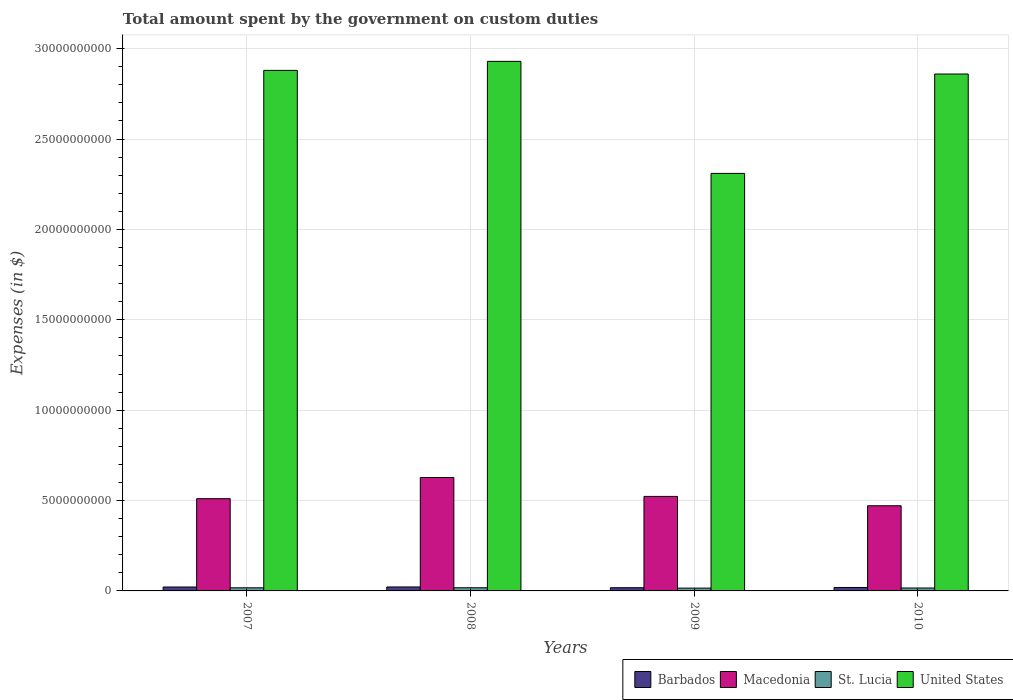How many groups of bars are there?
Ensure brevity in your answer.  4. Are the number of bars per tick equal to the number of legend labels?
Ensure brevity in your answer.  Yes. How many bars are there on the 2nd tick from the left?
Keep it short and to the point. 4. How many bars are there on the 4th tick from the right?
Give a very brief answer. 4. What is the label of the 2nd group of bars from the left?
Your answer should be compact. 2008. In how many cases, is the number of bars for a given year not equal to the number of legend labels?
Offer a very short reply. 0. What is the amount spent on custom duties by the government in United States in 2010?
Your answer should be very brief. 2.86e+1. Across all years, what is the maximum amount spent on custom duties by the government in United States?
Offer a terse response. 2.93e+1. Across all years, what is the minimum amount spent on custom duties by the government in Barbados?
Make the answer very short. 1.78e+08. In which year was the amount spent on custom duties by the government in United States maximum?
Offer a very short reply. 2008. What is the total amount spent on custom duties by the government in Macedonia in the graph?
Provide a short and direct response. 2.13e+1. What is the difference between the amount spent on custom duties by the government in United States in 2007 and that in 2008?
Keep it short and to the point. -5.00e+08. What is the difference between the amount spent on custom duties by the government in United States in 2007 and the amount spent on custom duties by the government in Barbados in 2010?
Make the answer very short. 2.86e+1. What is the average amount spent on custom duties by the government in Barbados per year?
Give a very brief answer. 2.01e+08. In the year 2007, what is the difference between the amount spent on custom duties by the government in Barbados and amount spent on custom duties by the government in Macedonia?
Give a very brief answer. -4.89e+09. In how many years, is the amount spent on custom duties by the government in United States greater than 23000000000 $?
Offer a terse response. 4. What is the ratio of the amount spent on custom duties by the government in St. Lucia in 2009 to that in 2010?
Your response must be concise. 0.96. Is the difference between the amount spent on custom duties by the government in Barbados in 2008 and 2009 greater than the difference between the amount spent on custom duties by the government in Macedonia in 2008 and 2009?
Your answer should be very brief. No. What is the difference between the highest and the second highest amount spent on custom duties by the government in St. Lucia?
Provide a short and direct response. 3.30e+06. What is the difference between the highest and the lowest amount spent on custom duties by the government in St. Lucia?
Your answer should be compact. 2.05e+07. What does the 1st bar from the left in 2008 represents?
Your answer should be compact. Barbados. What does the 3rd bar from the right in 2010 represents?
Ensure brevity in your answer.  Macedonia. Is it the case that in every year, the sum of the amount spent on custom duties by the government in Barbados and amount spent on custom duties by the government in United States is greater than the amount spent on custom duties by the government in Macedonia?
Provide a short and direct response. Yes. How many bars are there?
Provide a short and direct response. 16. How many years are there in the graph?
Provide a short and direct response. 4. What is the difference between two consecutive major ticks on the Y-axis?
Your answer should be very brief. 5.00e+09. Does the graph contain grids?
Your response must be concise. Yes. How are the legend labels stacked?
Make the answer very short. Horizontal. What is the title of the graph?
Give a very brief answer. Total amount spent by the government on custom duties. Does "Congo (Republic)" appear as one of the legend labels in the graph?
Offer a terse response. No. What is the label or title of the Y-axis?
Your answer should be very brief. Expenses (in $). What is the Expenses (in $) in Barbados in 2007?
Your answer should be compact. 2.17e+08. What is the Expenses (in $) in Macedonia in 2007?
Offer a terse response. 5.10e+09. What is the Expenses (in $) in St. Lucia in 2007?
Keep it short and to the point. 1.72e+08. What is the Expenses (in $) of United States in 2007?
Your response must be concise. 2.88e+1. What is the Expenses (in $) in Barbados in 2008?
Your answer should be compact. 2.19e+08. What is the Expenses (in $) of Macedonia in 2008?
Your answer should be compact. 6.28e+09. What is the Expenses (in $) in St. Lucia in 2008?
Your response must be concise. 1.75e+08. What is the Expenses (in $) of United States in 2008?
Ensure brevity in your answer.  2.93e+1. What is the Expenses (in $) of Barbados in 2009?
Make the answer very short. 1.78e+08. What is the Expenses (in $) in Macedonia in 2009?
Give a very brief answer. 5.23e+09. What is the Expenses (in $) of St. Lucia in 2009?
Provide a succinct answer. 1.55e+08. What is the Expenses (in $) of United States in 2009?
Your answer should be very brief. 2.31e+1. What is the Expenses (in $) of Barbados in 2010?
Give a very brief answer. 1.91e+08. What is the Expenses (in $) of Macedonia in 2010?
Give a very brief answer. 4.71e+09. What is the Expenses (in $) in St. Lucia in 2010?
Offer a terse response. 1.61e+08. What is the Expenses (in $) in United States in 2010?
Ensure brevity in your answer.  2.86e+1. Across all years, what is the maximum Expenses (in $) in Barbados?
Your answer should be very brief. 2.19e+08. Across all years, what is the maximum Expenses (in $) in Macedonia?
Provide a succinct answer. 6.28e+09. Across all years, what is the maximum Expenses (in $) in St. Lucia?
Your answer should be very brief. 1.75e+08. Across all years, what is the maximum Expenses (in $) of United States?
Ensure brevity in your answer.  2.93e+1. Across all years, what is the minimum Expenses (in $) of Barbados?
Make the answer very short. 1.78e+08. Across all years, what is the minimum Expenses (in $) of Macedonia?
Keep it short and to the point. 4.71e+09. Across all years, what is the minimum Expenses (in $) in St. Lucia?
Keep it short and to the point. 1.55e+08. Across all years, what is the minimum Expenses (in $) of United States?
Offer a terse response. 2.31e+1. What is the total Expenses (in $) in Barbados in the graph?
Your response must be concise. 8.05e+08. What is the total Expenses (in $) in Macedonia in the graph?
Your response must be concise. 2.13e+1. What is the total Expenses (in $) of St. Lucia in the graph?
Provide a short and direct response. 6.64e+08. What is the total Expenses (in $) in United States in the graph?
Provide a short and direct response. 1.10e+11. What is the difference between the Expenses (in $) of Barbados in 2007 and that in 2008?
Provide a short and direct response. -2.52e+06. What is the difference between the Expenses (in $) of Macedonia in 2007 and that in 2008?
Ensure brevity in your answer.  -1.17e+09. What is the difference between the Expenses (in $) in St. Lucia in 2007 and that in 2008?
Ensure brevity in your answer.  -3.30e+06. What is the difference between the Expenses (in $) in United States in 2007 and that in 2008?
Ensure brevity in your answer.  -5.00e+08. What is the difference between the Expenses (in $) in Barbados in 2007 and that in 2009?
Your answer should be very brief. 3.90e+07. What is the difference between the Expenses (in $) of Macedonia in 2007 and that in 2009?
Your answer should be compact. -1.26e+08. What is the difference between the Expenses (in $) in St. Lucia in 2007 and that in 2009?
Offer a terse response. 1.72e+07. What is the difference between the Expenses (in $) in United States in 2007 and that in 2009?
Make the answer very short. 5.70e+09. What is the difference between the Expenses (in $) of Barbados in 2007 and that in 2010?
Offer a terse response. 2.61e+07. What is the difference between the Expenses (in $) of Macedonia in 2007 and that in 2010?
Offer a very short reply. 3.91e+08. What is the difference between the Expenses (in $) of St. Lucia in 2007 and that in 2010?
Offer a very short reply. 1.10e+07. What is the difference between the Expenses (in $) of United States in 2007 and that in 2010?
Your answer should be very brief. 2.00e+08. What is the difference between the Expenses (in $) of Barbados in 2008 and that in 2009?
Your answer should be compact. 4.15e+07. What is the difference between the Expenses (in $) in Macedonia in 2008 and that in 2009?
Provide a succinct answer. 1.05e+09. What is the difference between the Expenses (in $) of St. Lucia in 2008 and that in 2009?
Give a very brief answer. 2.05e+07. What is the difference between the Expenses (in $) in United States in 2008 and that in 2009?
Offer a terse response. 6.20e+09. What is the difference between the Expenses (in $) in Barbados in 2008 and that in 2010?
Your answer should be compact. 2.87e+07. What is the difference between the Expenses (in $) of Macedonia in 2008 and that in 2010?
Your answer should be compact. 1.56e+09. What is the difference between the Expenses (in $) of St. Lucia in 2008 and that in 2010?
Make the answer very short. 1.43e+07. What is the difference between the Expenses (in $) of United States in 2008 and that in 2010?
Your response must be concise. 7.00e+08. What is the difference between the Expenses (in $) in Barbados in 2009 and that in 2010?
Offer a very short reply. -1.28e+07. What is the difference between the Expenses (in $) of Macedonia in 2009 and that in 2010?
Offer a very short reply. 5.17e+08. What is the difference between the Expenses (in $) of St. Lucia in 2009 and that in 2010?
Make the answer very short. -6.20e+06. What is the difference between the Expenses (in $) in United States in 2009 and that in 2010?
Ensure brevity in your answer.  -5.50e+09. What is the difference between the Expenses (in $) of Barbados in 2007 and the Expenses (in $) of Macedonia in 2008?
Offer a terse response. -6.06e+09. What is the difference between the Expenses (in $) of Barbados in 2007 and the Expenses (in $) of St. Lucia in 2008?
Your answer should be compact. 4.15e+07. What is the difference between the Expenses (in $) in Barbados in 2007 and the Expenses (in $) in United States in 2008?
Provide a short and direct response. -2.91e+1. What is the difference between the Expenses (in $) of Macedonia in 2007 and the Expenses (in $) of St. Lucia in 2008?
Give a very brief answer. 4.93e+09. What is the difference between the Expenses (in $) in Macedonia in 2007 and the Expenses (in $) in United States in 2008?
Your answer should be compact. -2.42e+1. What is the difference between the Expenses (in $) in St. Lucia in 2007 and the Expenses (in $) in United States in 2008?
Keep it short and to the point. -2.91e+1. What is the difference between the Expenses (in $) in Barbados in 2007 and the Expenses (in $) in Macedonia in 2009?
Ensure brevity in your answer.  -5.01e+09. What is the difference between the Expenses (in $) of Barbados in 2007 and the Expenses (in $) of St. Lucia in 2009?
Your response must be concise. 6.20e+07. What is the difference between the Expenses (in $) of Barbados in 2007 and the Expenses (in $) of United States in 2009?
Offer a very short reply. -2.29e+1. What is the difference between the Expenses (in $) in Macedonia in 2007 and the Expenses (in $) in St. Lucia in 2009?
Provide a succinct answer. 4.95e+09. What is the difference between the Expenses (in $) in Macedonia in 2007 and the Expenses (in $) in United States in 2009?
Ensure brevity in your answer.  -1.80e+1. What is the difference between the Expenses (in $) of St. Lucia in 2007 and the Expenses (in $) of United States in 2009?
Provide a short and direct response. -2.29e+1. What is the difference between the Expenses (in $) in Barbados in 2007 and the Expenses (in $) in Macedonia in 2010?
Your answer should be very brief. -4.50e+09. What is the difference between the Expenses (in $) of Barbados in 2007 and the Expenses (in $) of St. Lucia in 2010?
Provide a short and direct response. 5.58e+07. What is the difference between the Expenses (in $) of Barbados in 2007 and the Expenses (in $) of United States in 2010?
Keep it short and to the point. -2.84e+1. What is the difference between the Expenses (in $) of Macedonia in 2007 and the Expenses (in $) of St. Lucia in 2010?
Provide a short and direct response. 4.94e+09. What is the difference between the Expenses (in $) in Macedonia in 2007 and the Expenses (in $) in United States in 2010?
Provide a short and direct response. -2.35e+1. What is the difference between the Expenses (in $) of St. Lucia in 2007 and the Expenses (in $) of United States in 2010?
Offer a terse response. -2.84e+1. What is the difference between the Expenses (in $) in Barbados in 2008 and the Expenses (in $) in Macedonia in 2009?
Your answer should be very brief. -5.01e+09. What is the difference between the Expenses (in $) of Barbados in 2008 and the Expenses (in $) of St. Lucia in 2009?
Offer a very short reply. 6.46e+07. What is the difference between the Expenses (in $) of Barbados in 2008 and the Expenses (in $) of United States in 2009?
Offer a very short reply. -2.29e+1. What is the difference between the Expenses (in $) of Macedonia in 2008 and the Expenses (in $) of St. Lucia in 2009?
Your answer should be compact. 6.12e+09. What is the difference between the Expenses (in $) of Macedonia in 2008 and the Expenses (in $) of United States in 2009?
Offer a very short reply. -1.68e+1. What is the difference between the Expenses (in $) in St. Lucia in 2008 and the Expenses (in $) in United States in 2009?
Your response must be concise. -2.29e+1. What is the difference between the Expenses (in $) in Barbados in 2008 and the Expenses (in $) in Macedonia in 2010?
Your answer should be very brief. -4.49e+09. What is the difference between the Expenses (in $) of Barbados in 2008 and the Expenses (in $) of St. Lucia in 2010?
Offer a terse response. 5.84e+07. What is the difference between the Expenses (in $) in Barbados in 2008 and the Expenses (in $) in United States in 2010?
Your response must be concise. -2.84e+1. What is the difference between the Expenses (in $) of Macedonia in 2008 and the Expenses (in $) of St. Lucia in 2010?
Make the answer very short. 6.11e+09. What is the difference between the Expenses (in $) in Macedonia in 2008 and the Expenses (in $) in United States in 2010?
Keep it short and to the point. -2.23e+1. What is the difference between the Expenses (in $) of St. Lucia in 2008 and the Expenses (in $) of United States in 2010?
Offer a terse response. -2.84e+1. What is the difference between the Expenses (in $) of Barbados in 2009 and the Expenses (in $) of Macedonia in 2010?
Provide a short and direct response. -4.53e+09. What is the difference between the Expenses (in $) of Barbados in 2009 and the Expenses (in $) of St. Lucia in 2010?
Offer a terse response. 1.69e+07. What is the difference between the Expenses (in $) of Barbados in 2009 and the Expenses (in $) of United States in 2010?
Ensure brevity in your answer.  -2.84e+1. What is the difference between the Expenses (in $) in Macedonia in 2009 and the Expenses (in $) in St. Lucia in 2010?
Offer a very short reply. 5.07e+09. What is the difference between the Expenses (in $) in Macedonia in 2009 and the Expenses (in $) in United States in 2010?
Ensure brevity in your answer.  -2.34e+1. What is the difference between the Expenses (in $) in St. Lucia in 2009 and the Expenses (in $) in United States in 2010?
Ensure brevity in your answer.  -2.84e+1. What is the average Expenses (in $) in Barbados per year?
Give a very brief answer. 2.01e+08. What is the average Expenses (in $) in Macedonia per year?
Provide a short and direct response. 5.33e+09. What is the average Expenses (in $) in St. Lucia per year?
Make the answer very short. 1.66e+08. What is the average Expenses (in $) of United States per year?
Your answer should be compact. 2.74e+1. In the year 2007, what is the difference between the Expenses (in $) in Barbados and Expenses (in $) in Macedonia?
Ensure brevity in your answer.  -4.89e+09. In the year 2007, what is the difference between the Expenses (in $) of Barbados and Expenses (in $) of St. Lucia?
Your answer should be compact. 4.48e+07. In the year 2007, what is the difference between the Expenses (in $) of Barbados and Expenses (in $) of United States?
Your response must be concise. -2.86e+1. In the year 2007, what is the difference between the Expenses (in $) of Macedonia and Expenses (in $) of St. Lucia?
Ensure brevity in your answer.  4.93e+09. In the year 2007, what is the difference between the Expenses (in $) in Macedonia and Expenses (in $) in United States?
Give a very brief answer. -2.37e+1. In the year 2007, what is the difference between the Expenses (in $) of St. Lucia and Expenses (in $) of United States?
Make the answer very short. -2.86e+1. In the year 2008, what is the difference between the Expenses (in $) in Barbados and Expenses (in $) in Macedonia?
Make the answer very short. -6.06e+09. In the year 2008, what is the difference between the Expenses (in $) of Barbados and Expenses (in $) of St. Lucia?
Offer a terse response. 4.41e+07. In the year 2008, what is the difference between the Expenses (in $) of Barbados and Expenses (in $) of United States?
Offer a terse response. -2.91e+1. In the year 2008, what is the difference between the Expenses (in $) of Macedonia and Expenses (in $) of St. Lucia?
Your answer should be very brief. 6.10e+09. In the year 2008, what is the difference between the Expenses (in $) in Macedonia and Expenses (in $) in United States?
Ensure brevity in your answer.  -2.30e+1. In the year 2008, what is the difference between the Expenses (in $) of St. Lucia and Expenses (in $) of United States?
Give a very brief answer. -2.91e+1. In the year 2009, what is the difference between the Expenses (in $) in Barbados and Expenses (in $) in Macedonia?
Your answer should be compact. -5.05e+09. In the year 2009, what is the difference between the Expenses (in $) of Barbados and Expenses (in $) of St. Lucia?
Provide a succinct answer. 2.31e+07. In the year 2009, what is the difference between the Expenses (in $) of Barbados and Expenses (in $) of United States?
Your response must be concise. -2.29e+1. In the year 2009, what is the difference between the Expenses (in $) in Macedonia and Expenses (in $) in St. Lucia?
Your response must be concise. 5.07e+09. In the year 2009, what is the difference between the Expenses (in $) of Macedonia and Expenses (in $) of United States?
Provide a succinct answer. -1.79e+1. In the year 2009, what is the difference between the Expenses (in $) of St. Lucia and Expenses (in $) of United States?
Keep it short and to the point. -2.29e+1. In the year 2010, what is the difference between the Expenses (in $) of Barbados and Expenses (in $) of Macedonia?
Ensure brevity in your answer.  -4.52e+09. In the year 2010, what is the difference between the Expenses (in $) in Barbados and Expenses (in $) in St. Lucia?
Offer a terse response. 2.97e+07. In the year 2010, what is the difference between the Expenses (in $) in Barbados and Expenses (in $) in United States?
Provide a succinct answer. -2.84e+1. In the year 2010, what is the difference between the Expenses (in $) of Macedonia and Expenses (in $) of St. Lucia?
Your response must be concise. 4.55e+09. In the year 2010, what is the difference between the Expenses (in $) of Macedonia and Expenses (in $) of United States?
Offer a very short reply. -2.39e+1. In the year 2010, what is the difference between the Expenses (in $) in St. Lucia and Expenses (in $) in United States?
Your answer should be very brief. -2.84e+1. What is the ratio of the Expenses (in $) of Barbados in 2007 to that in 2008?
Your answer should be very brief. 0.99. What is the ratio of the Expenses (in $) of Macedonia in 2007 to that in 2008?
Your response must be concise. 0.81. What is the ratio of the Expenses (in $) of St. Lucia in 2007 to that in 2008?
Your answer should be compact. 0.98. What is the ratio of the Expenses (in $) in United States in 2007 to that in 2008?
Your answer should be compact. 0.98. What is the ratio of the Expenses (in $) of Barbados in 2007 to that in 2009?
Offer a terse response. 1.22. What is the ratio of the Expenses (in $) in Macedonia in 2007 to that in 2009?
Make the answer very short. 0.98. What is the ratio of the Expenses (in $) in St. Lucia in 2007 to that in 2009?
Give a very brief answer. 1.11. What is the ratio of the Expenses (in $) of United States in 2007 to that in 2009?
Offer a terse response. 1.25. What is the ratio of the Expenses (in $) of Barbados in 2007 to that in 2010?
Give a very brief answer. 1.14. What is the ratio of the Expenses (in $) in Macedonia in 2007 to that in 2010?
Keep it short and to the point. 1.08. What is the ratio of the Expenses (in $) in St. Lucia in 2007 to that in 2010?
Make the answer very short. 1.07. What is the ratio of the Expenses (in $) of Barbados in 2008 to that in 2009?
Give a very brief answer. 1.23. What is the ratio of the Expenses (in $) in St. Lucia in 2008 to that in 2009?
Offer a terse response. 1.13. What is the ratio of the Expenses (in $) in United States in 2008 to that in 2009?
Your answer should be compact. 1.27. What is the ratio of the Expenses (in $) in Barbados in 2008 to that in 2010?
Your response must be concise. 1.15. What is the ratio of the Expenses (in $) in Macedonia in 2008 to that in 2010?
Ensure brevity in your answer.  1.33. What is the ratio of the Expenses (in $) of St. Lucia in 2008 to that in 2010?
Offer a terse response. 1.09. What is the ratio of the Expenses (in $) in United States in 2008 to that in 2010?
Provide a succinct answer. 1.02. What is the ratio of the Expenses (in $) of Barbados in 2009 to that in 2010?
Provide a succinct answer. 0.93. What is the ratio of the Expenses (in $) in Macedonia in 2009 to that in 2010?
Give a very brief answer. 1.11. What is the ratio of the Expenses (in $) in St. Lucia in 2009 to that in 2010?
Give a very brief answer. 0.96. What is the ratio of the Expenses (in $) in United States in 2009 to that in 2010?
Your answer should be compact. 0.81. What is the difference between the highest and the second highest Expenses (in $) of Barbados?
Ensure brevity in your answer.  2.52e+06. What is the difference between the highest and the second highest Expenses (in $) of Macedonia?
Your answer should be very brief. 1.05e+09. What is the difference between the highest and the second highest Expenses (in $) in St. Lucia?
Give a very brief answer. 3.30e+06. What is the difference between the highest and the lowest Expenses (in $) in Barbados?
Keep it short and to the point. 4.15e+07. What is the difference between the highest and the lowest Expenses (in $) in Macedonia?
Offer a terse response. 1.56e+09. What is the difference between the highest and the lowest Expenses (in $) of St. Lucia?
Provide a succinct answer. 2.05e+07. What is the difference between the highest and the lowest Expenses (in $) of United States?
Provide a succinct answer. 6.20e+09. 